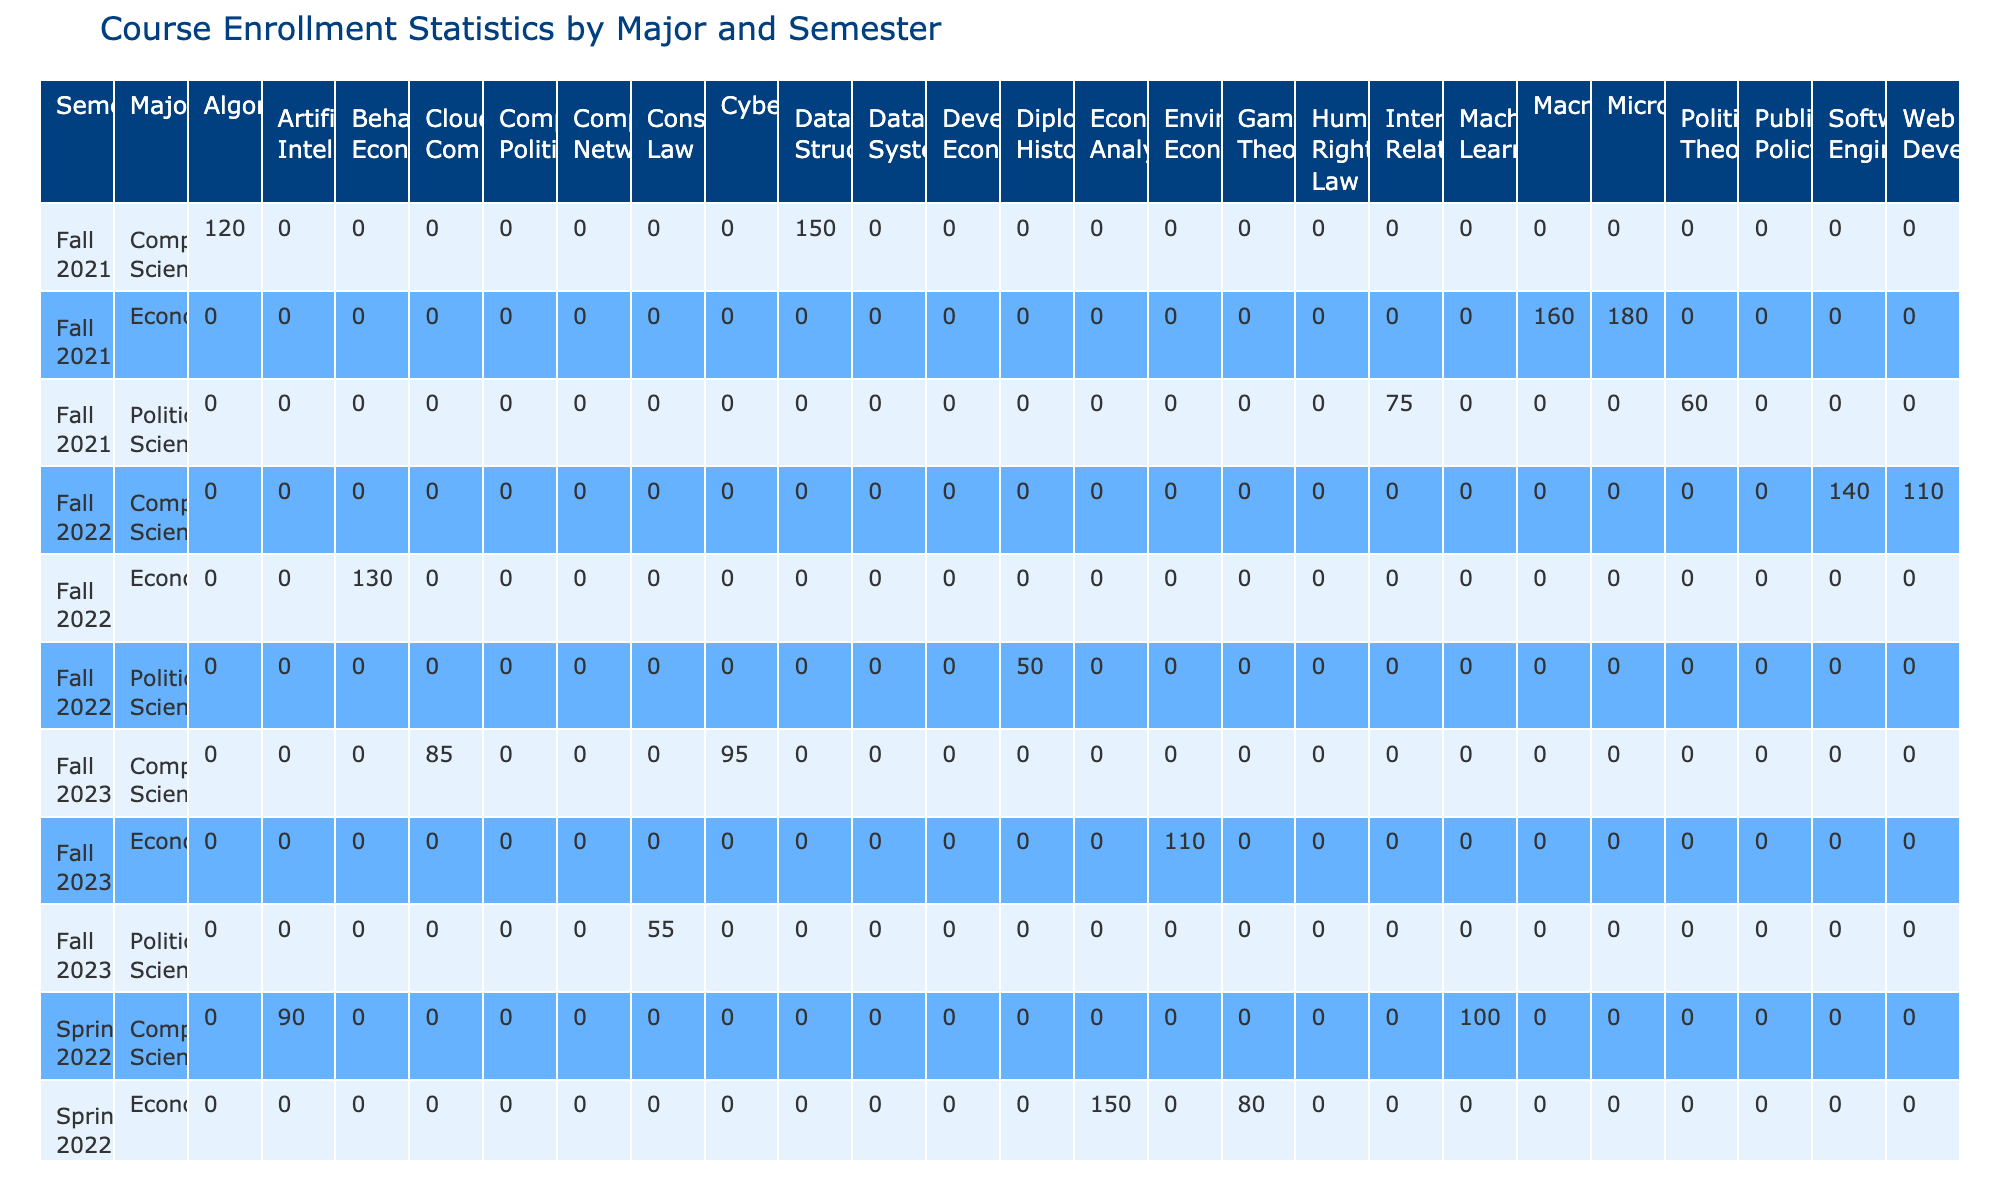What is the enrollment for Data Structures in Fall 2021? The table indicates that the enrollment for Data Structures under the Computer Science major for Fall 2021 is listed directly in the corresponding cell. It shows an enrollment of 150 students.
Answer: 150 What is the total enrollment for Economics courses in Spring 2022? To find the total enrollment for Economics courses in Spring 2022, we add the enrollments for Econometric Analysis (150) and Game Theory (80), which equals 230.
Answer: 230 Was the enrollment for Political Science courses in Fall 2022 higher than in Fall 2021? We compare the total enrollments: In Fall 2021, the total for Political Science (International Relations 75 + Political Theory 60) is 135, while in Fall 2022 (Diplomatic History 50) it’s 50. Thus, Fall 2021 had higher enrollment.
Answer: No What is the difference in enrollment for Algorithms between Fall 2021 and Cloud Computing in Fall 2023? The enrollment for Algorithms in Fall 2021 is 120, and for Cloud Computing in Fall 2023 is 85. The difference is 120 - 85 = 35, meaning Algorithms had 35 more students.
Answer: 35 Which major had the highest single course enrollment in Fall 2021? Looking through the courses listed for Fall 2021, Microeconomics has the highest enrollment at 180, as compared to other courses across majors.
Answer: Economics What was the average enrollment for Computer Science courses across all semesters in the table? We sum the enrollments for Computer Science: 150 (Data Structures) + 120 (Algorithms) + 100 (Machine Learning) + 90 (Artificial Intelligence) + 140 (Software Engineering) + 110 (Web Development) + 75 (Database Systems) + 80 (Computer Networks) + 85 (Cloud Computing) + 95 (Cybersecurity) = 1,050. There are 10 courses total, so the average is 1,050 / 10 = 105.
Answer: 105 Did any Political Science course in Spring 2023 have an enrollment of more than 50? Checking the enrollments for Political Science courses in Spring 2023, Human Rights Law has an enrollment of 40, which is less than 50, and no other courses are listed. So, there are no courses exceeding 50.
Answer: No What is the total enrollment for all courses in Fall 2023? We need to add the enrollments for all courses listed in Fall 2023: Cloud Computing 85 + Cybersecurity 95 + Environmental Economics 110 + Constitutional Law 55 = 445. Thus, the total enrollment for all courses in that semester is 445.
Answer: 445 Which course had the lowest enrollment in Spring 2022, and what was that enrollment? By reviewing the Spring 2022 enrollment numbers, we find that Comparative Politics had the lowest enrollment at 65 students, while Public Policy has 70.
Answer: Comparative Politics, 65 Is the enrollment for Environmental Economics in Fall 2023 greater than the average enrollment for Political Science courses across all semesters? The enrollment for Environmental Economics is 110. To find the average Political Science enrollment, we calculate: (75 + 60 + 70 + 65 + 50 + 40 + 55) = 475, divided by 7 = approximately 67.86. Since 110 is greater than 67.86, it is indeed greater.
Answer: Yes What is the total enrollment difference between Computer Science and Economics courses in Fall 2022? Adding the enrollments: Computer Science (Software Engineering 140 + Web Development 110 = 250), and Economics (Behavioral Economics 130). The difference is 250 - 130 = 120.
Answer: 120 